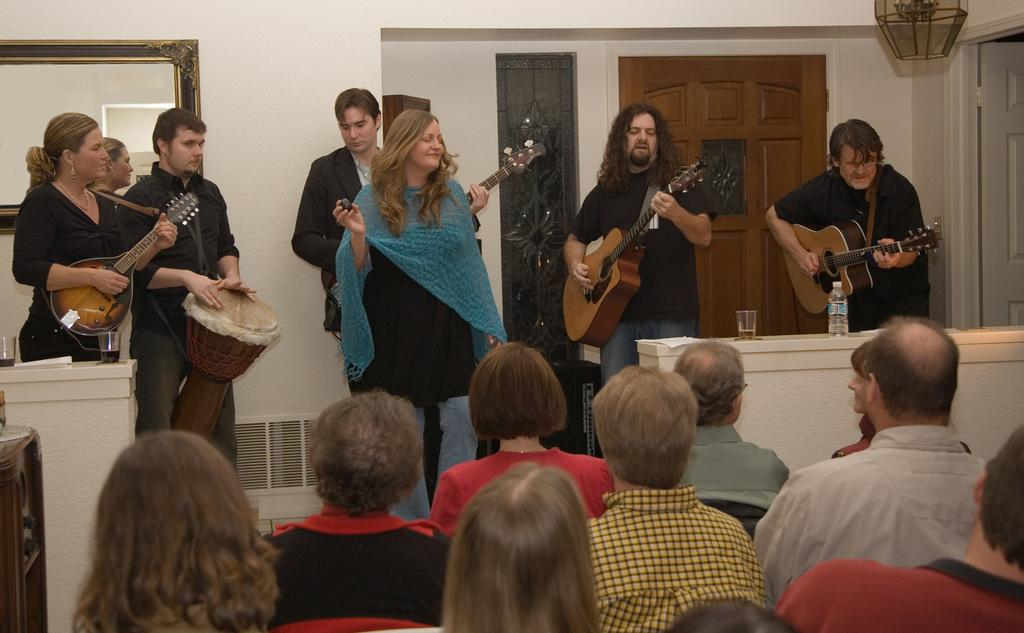What are the people in the image doing? The people in the image are standing and sitting, watching something or someone. What are the men holding in their hands? Some men are holding guitars and drums in their hands. Can you describe the actions of the people in the image? The people are watching something or someone, and some men are holding musical instruments. What is the aftermath of the careless form in the image? There is no mention of an aftermath or careless form in the image; the people are simply watching something or someone, and some men are holding musical instruments. 